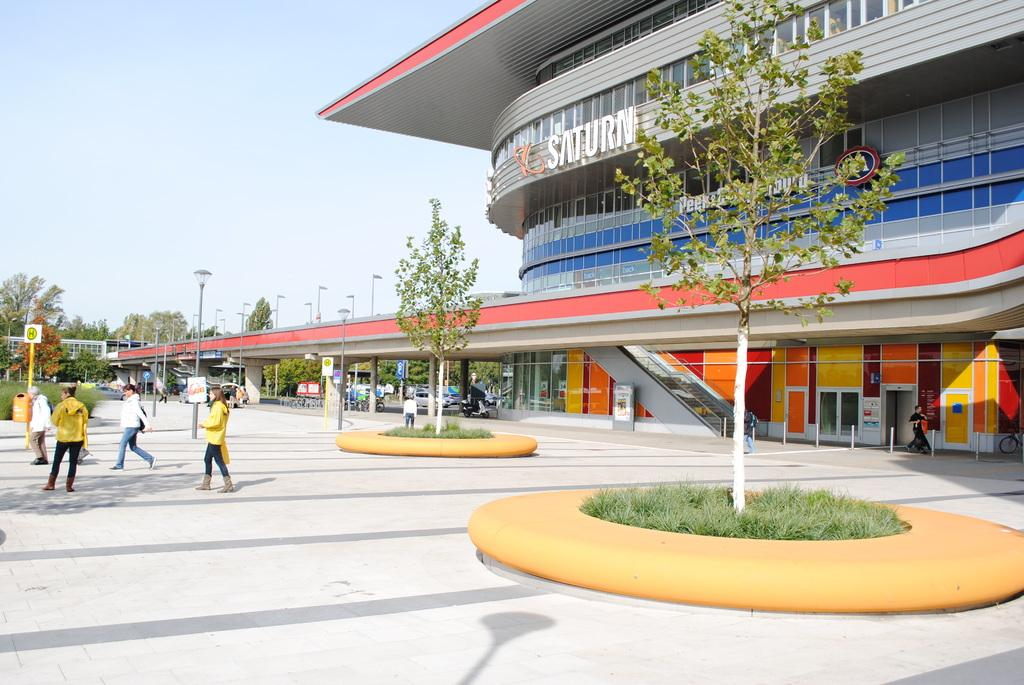<image>
Relay a brief, clear account of the picture shown. A colorful Saturn building is decorated with orange and yellow signs. 